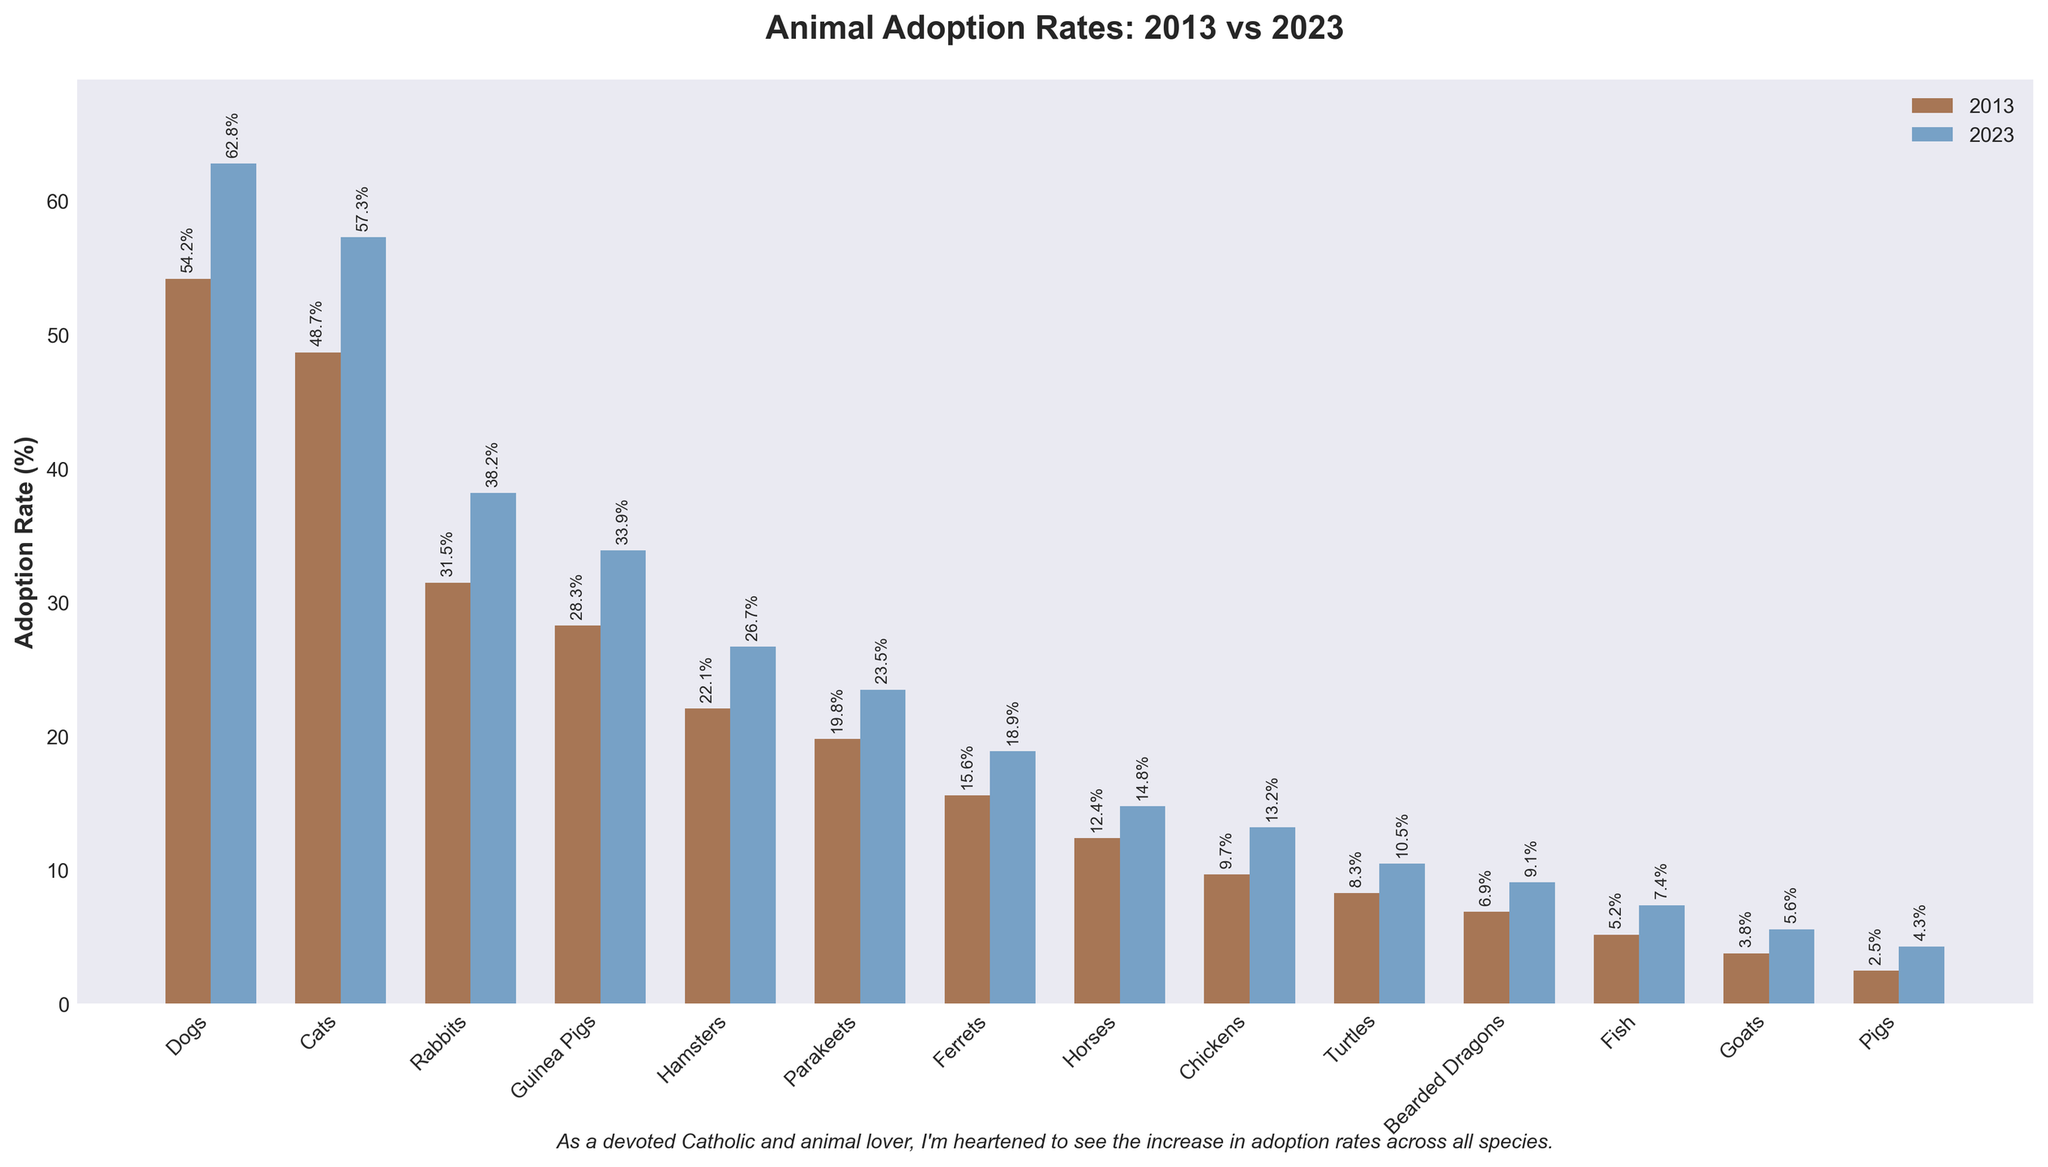Which animal species had the highest adoption rate in 2023? The tallest blue-colored bar represents the highest adoption rate for 2023. Dogs have the highest adoption rate at 62.8%.
Answer: Dogs Which animal species saw the greatest increase in adoption rate from 2013 to 2023? For each species, subtract the adoption rate in 2013 from the adoption rate in 2023. The highest increase is seen for Dogs (62.8% - 54.2% = 8.6%).
Answer: Dogs Which species had the lowest adoption rate in 2013, and what was the rate? Identify the shortest brown-colored bar, which represents 2013. It is for Pigs at 2.5%.
Answer: Pigs, 2.5% What is the average adoption rate for Cats and Rabbits combined in 2023? Add the adoption rates for Cats and Rabbits in 2023 (57.3% + 38.2%), then divide by 2. The average is (57.3 + 38.2) / 2 = 47.75%.
Answer: 47.75% Are the adoption rates for Turtles in 2013 greater than Parakeets in 2023? Compare the height of the brown bar for Turtles in 2013 (8.3%) to the blue bar for Parakeets in 2023 (23.5%). Since 8.3% < 23.5%, Turtles in 2013 are lower.
Answer: No What is the total adoption rate for Hamsters and Parakeets in 2023? Add the adoption rates of Hamsters and Parakeets in 2023 (26.7 + 23.5). The total is 26.7 + 23.5 = 50.2%.
Answer: 50.2% Which animal had the smallest increase in adoption rate from 2013 to 2023? Calculate the difference between 2023 and 2013 adoption rates for each species. The smallest increase is seen for Fish (7.4 - 5.2 = 2.2).
Answer: Fish By how much did Horses' adoption rate increase between 2013 and 2023? Subtract the adoption rate of Horses in 2013 from 2023. The increase is 14.8% - 12.4% = 2.4%.
Answer: 2.4% What is the total adoption rate in 2023 for the 3 species with the highest adoption rates? Identify the three species with the highest blue bars in 2023: Dogs (62.8), Cats (57.3), and Rabbits (38.2). Their total is 62.8 + 57.3 + 38.2 = 158.3%.
Answer: 158.3% 